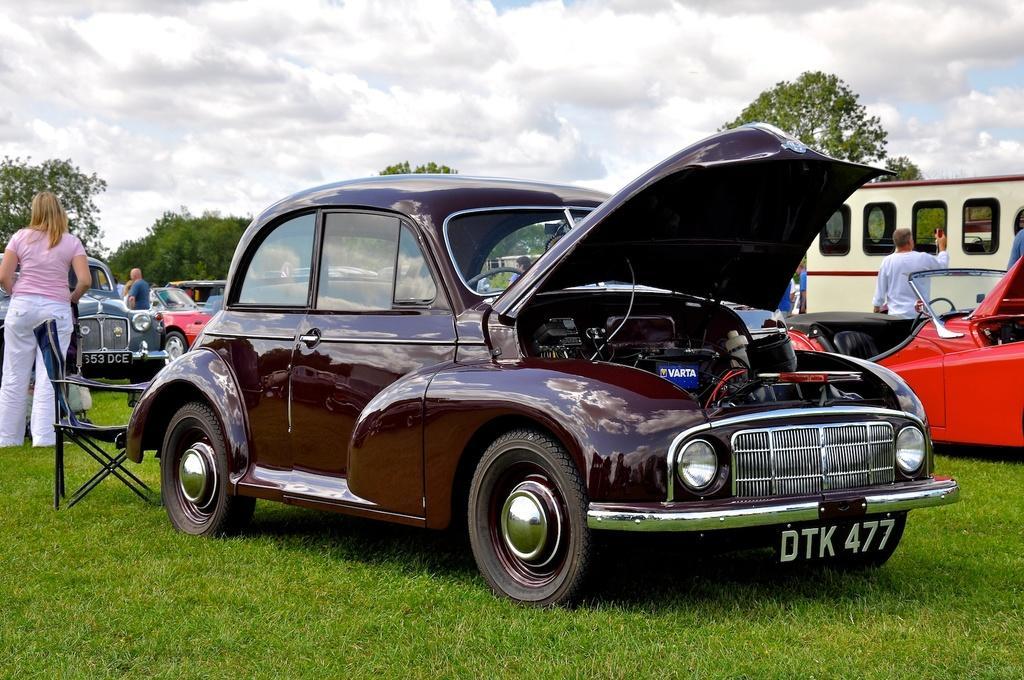Please provide a concise description of this image. In this image I can see few vehicles. In front the vehicle is in brown color, I can also see few persons standing. In front the person is wearing pink and white color dress, background I can see trees in green color and the sky is in white and blue color. 